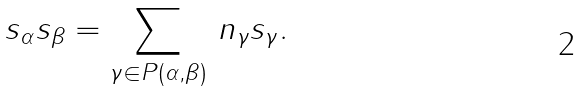Convert formula to latex. <formula><loc_0><loc_0><loc_500><loc_500>s _ { \alpha } s _ { \beta } = \sum _ { \gamma \in P ( \alpha , \beta ) } \, n _ { \gamma } s _ { \gamma } .</formula> 